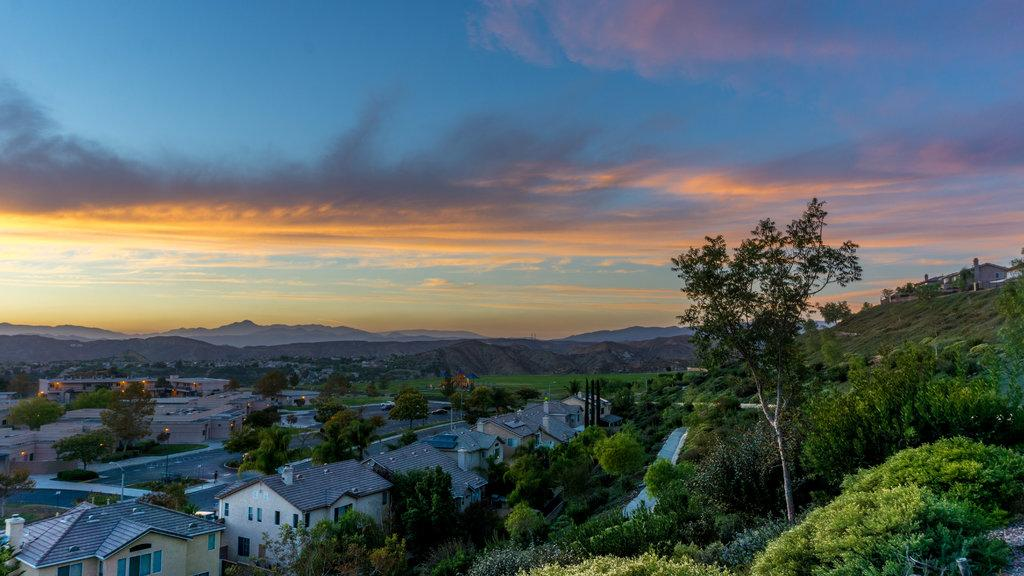What types of structures can be seen at the bottom of the image? There are houses, poles, lights, trees, plants, roads, and walls visible at the bottom of the image. What types of vehicles are present at the bottom of the image? There are vehicles at the bottom of the image. What can be seen in the background of the image? There are hills, houses, and the sky visible in the background of the image. How many banana trees can be seen in the image? There are no banana trees present in the image. What type of plantation is visible in the image? There is no plantation present in the image. 